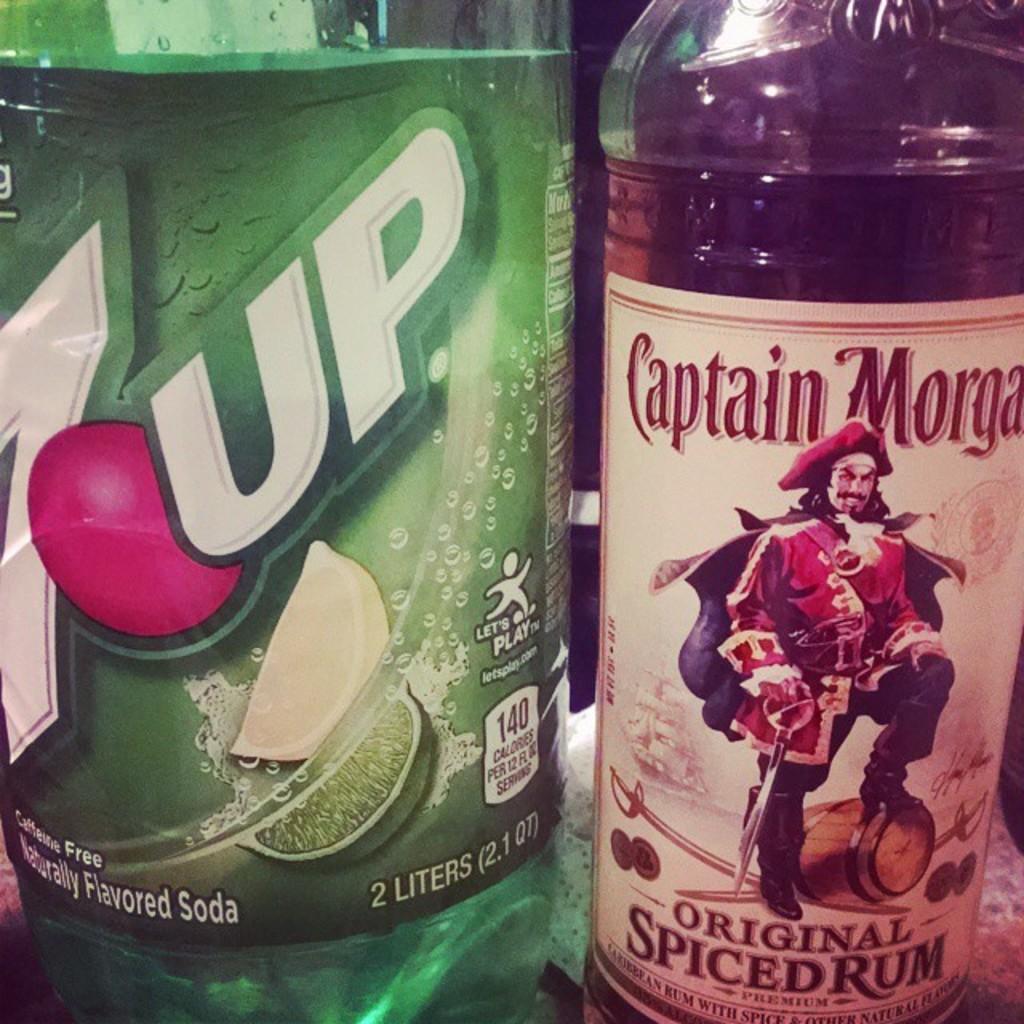What drinks are here?
Your answer should be very brief. 7up and captain morgan. What is the type of rum?
Make the answer very short. Spiced. 